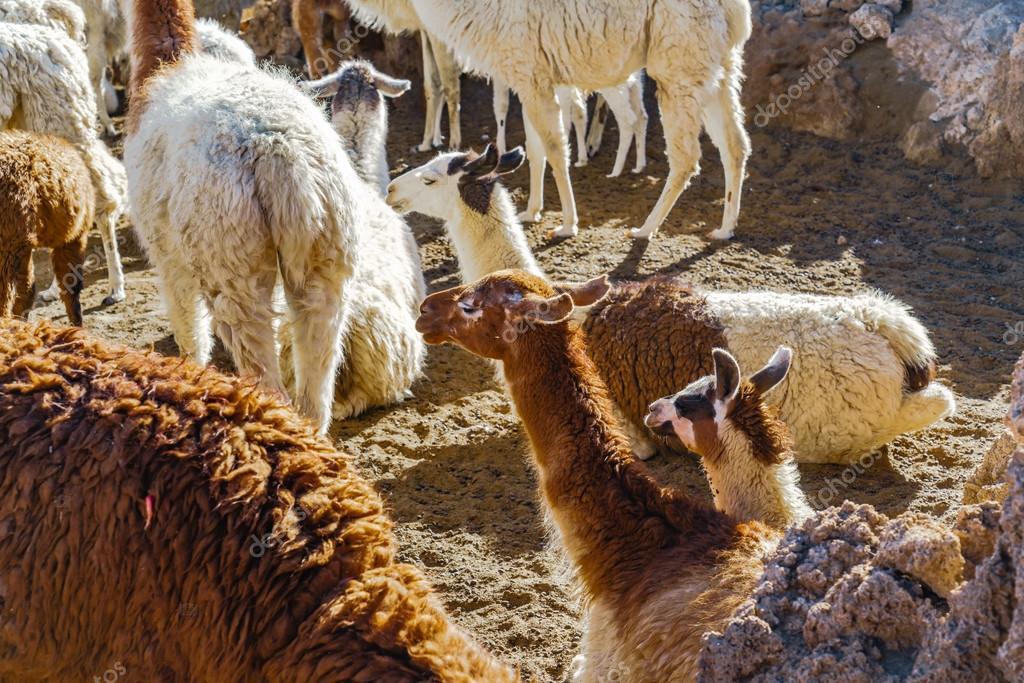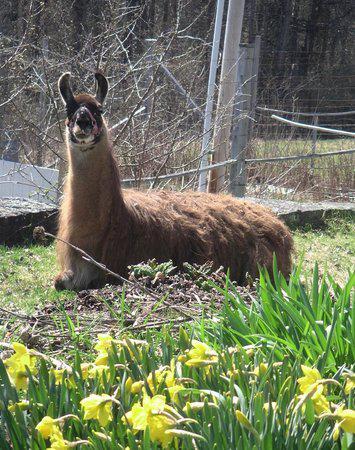The first image is the image on the left, the second image is the image on the right. For the images shown, is this caption "The right image contains one llama reclining with its body aimed leftward and its pright head turned forward." true? Answer yes or no. Yes. The first image is the image on the left, the second image is the image on the right. Considering the images on both sides, is "The left and right image contains no more than three total llamas." valid? Answer yes or no. No. 